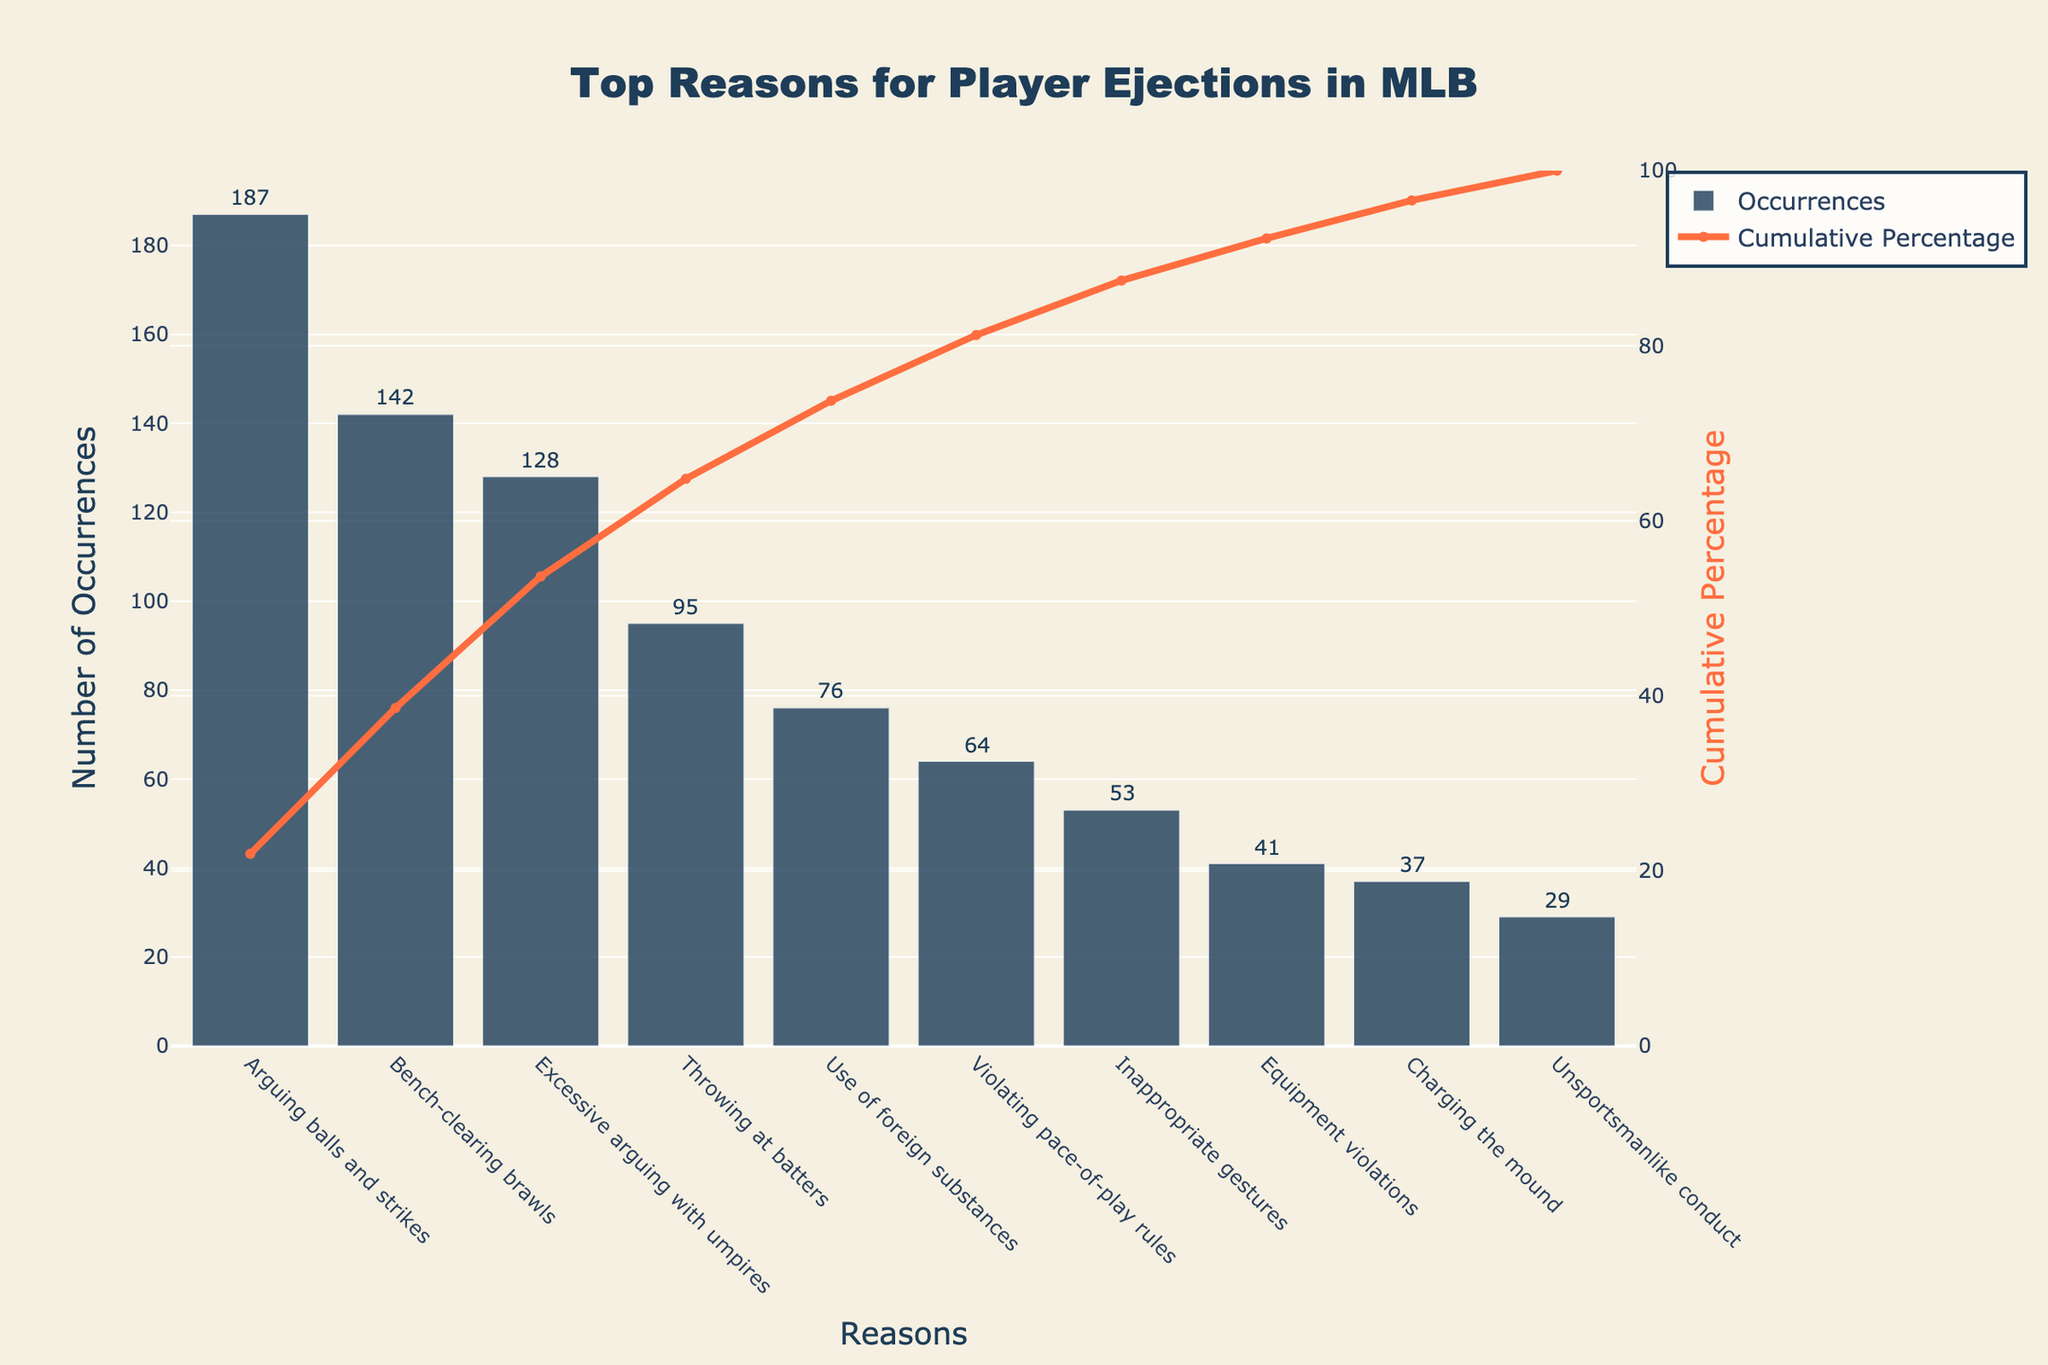How many reasons are listed for player ejections in MLB? There are 10 bars in the chart, each representing a different reason for player ejections. Counting these bars gives us the number of reasons.
Answer: 10 What is the title of the chart? The title of the chart is usually positioned at the top and is designed to give a clear idea of what the chart represents.
Answer: Top Reasons for Player Ejections in MLB Which reason has the highest number of occurrences? The 'Arguing balls and strikes' bar is the tallest, indicating it has the highest number of occurrences.
Answer: Arguing balls and strikes What is the cumulative percentage of occurrences for 'Excessive arguing with umpires'? Locate the point on the cumulative percentage line above the 'Excessive arguing with umpires' bar and read its value from the secondary y-axis on the right.
Answer: ~71% Which reason has the third-highest number of occurrences? The third tallest bar indicates the reason with the third-highest number of occurrences. In this case, it corresponds to 'Excessive arguing with umpires'.
Answer: Excessive arguing with umpires What is the sum of occurrences for 'Throwing at batters' and 'Unsportsmanlike conduct'? Add the occurrences for 'Throwing at batters' (95) and 'Unsportsmanlike conduct' (29).
Answer: 124 Is the occurrence of 'Use of foreign substances' greater than 'Violating pace-of-play rules'? Compare the heights of the bars for 'Use of foreign substances' (76) and 'Violating pace-of-play rules' (64).
Answer: Yes What cumulative percentage does 'Bench-clearing brawls' and 'Arguing balls and strikes' contribute together? Sum the occurrences of 'Bench-clearing brawls' (142) and 'Arguing balls and strikes' (187), then divide by the total occurrences and multiply by 100 to get the cumulative percentage.
Answer: ~46% How many occurrences are there total for all reasons combined? Sum all the occurrences from each bar: 187 + 142 + 128 + 95 + 76 + 64 + 53 + 41 + 37 + 29.
Answer: 852 Which reason was responsible for fewer ejections, 'Charging the mound' or 'Inappropriate gestures'? Compare the heights of the bars for 'Charging the mound' (37) and 'Inappropriate gestures' (53).
Answer: Charging the mound 